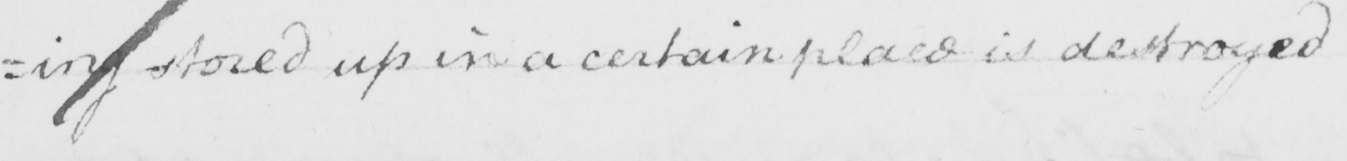Transcribe the text shown in this historical manuscript line. : ing stored up in a certain place is destroyed 